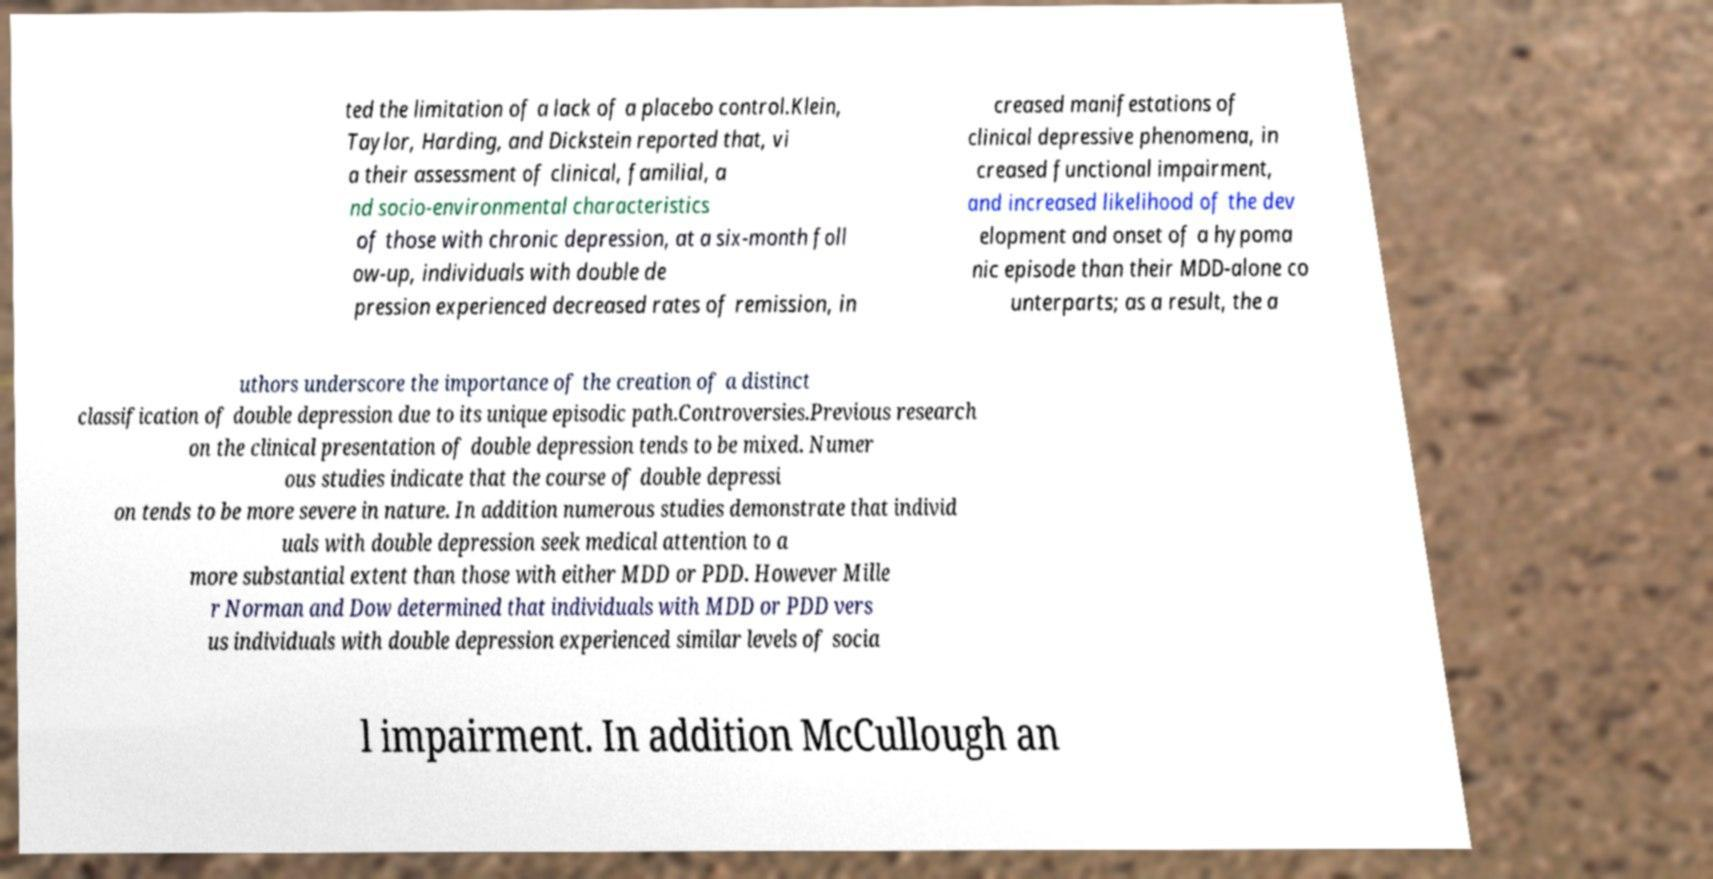Can you read and provide the text displayed in the image?This photo seems to have some interesting text. Can you extract and type it out for me? ted the limitation of a lack of a placebo control.Klein, Taylor, Harding, and Dickstein reported that, vi a their assessment of clinical, familial, a nd socio-environmental characteristics of those with chronic depression, at a six-month foll ow-up, individuals with double de pression experienced decreased rates of remission, in creased manifestations of clinical depressive phenomena, in creased functional impairment, and increased likelihood of the dev elopment and onset of a hypoma nic episode than their MDD-alone co unterparts; as a result, the a uthors underscore the importance of the creation of a distinct classification of double depression due to its unique episodic path.Controversies.Previous research on the clinical presentation of double depression tends to be mixed. Numer ous studies indicate that the course of double depressi on tends to be more severe in nature. In addition numerous studies demonstrate that individ uals with double depression seek medical attention to a more substantial extent than those with either MDD or PDD. However Mille r Norman and Dow determined that individuals with MDD or PDD vers us individuals with double depression experienced similar levels of socia l impairment. In addition McCullough an 